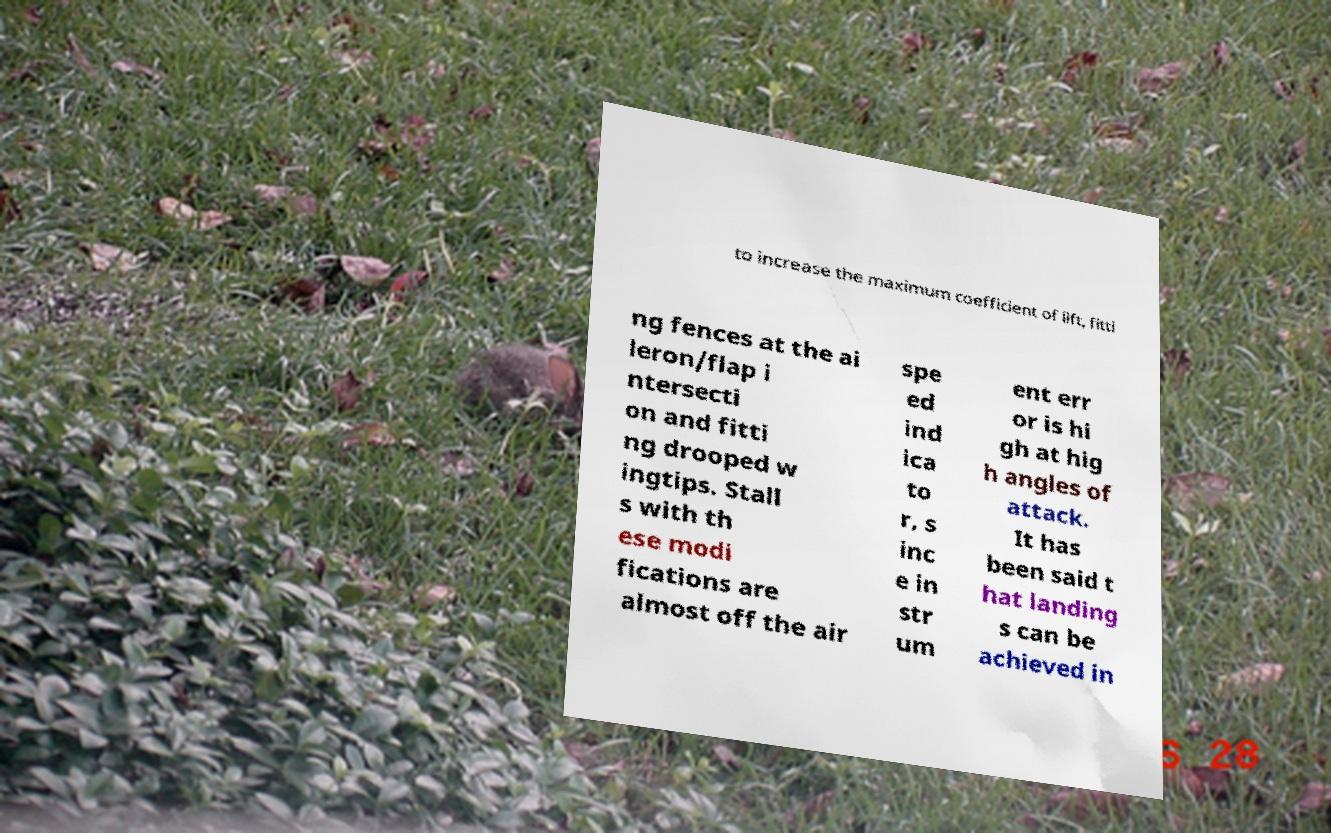Please read and relay the text visible in this image. What does it say? to increase the maximum coefficient of lift, fitti ng fences at the ai leron/flap i ntersecti on and fitti ng drooped w ingtips. Stall s with th ese modi fications are almost off the air spe ed ind ica to r, s inc e in str um ent err or is hi gh at hig h angles of attack. It has been said t hat landing s can be achieved in 